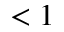<formula> <loc_0><loc_0><loc_500><loc_500>< 1</formula> 